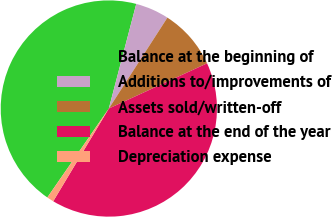Convert chart to OTSL. <chart><loc_0><loc_0><loc_500><loc_500><pie_chart><fcel>Balance at the beginning of<fcel>Additions to/improvements of<fcel>Assets sold/written-off<fcel>Balance at the end of the year<fcel>Depreciation expense<nl><fcel>44.46%<fcel>5.03%<fcel>9.03%<fcel>40.46%<fcel>1.03%<nl></chart> 